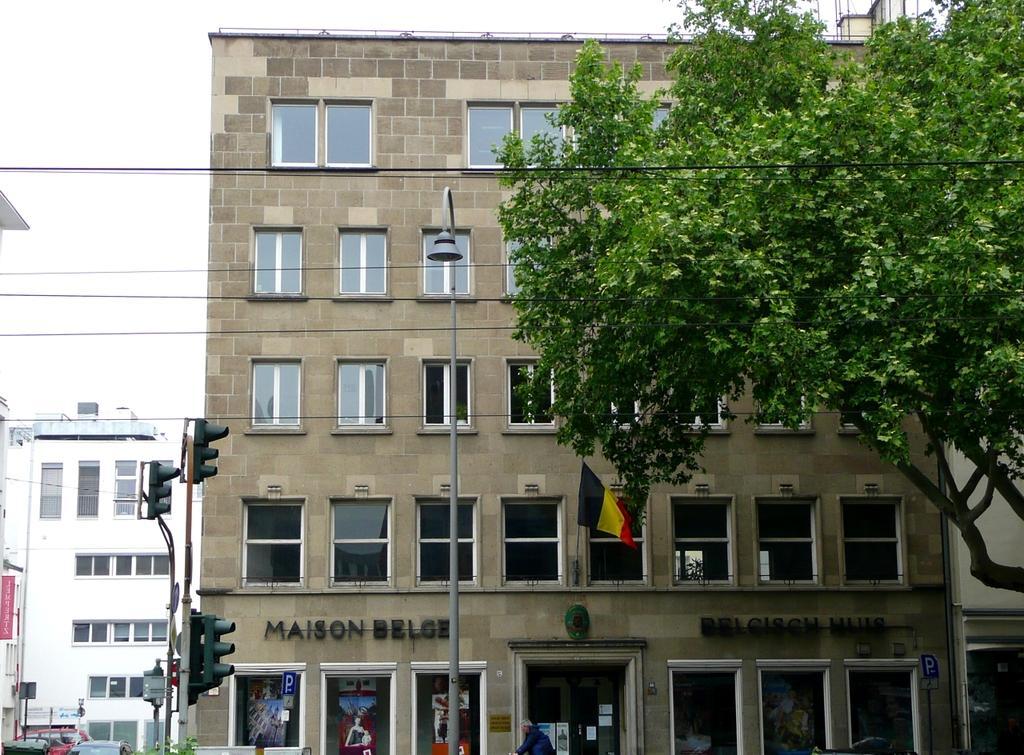Can you describe this image briefly? In this image we can see a building, glass windows, boards, traffic lights, street light, flag, tree, cables and other objects. On the left side of the image there are buildings, vehicles and other objects. In the background of the image there is the sky. 